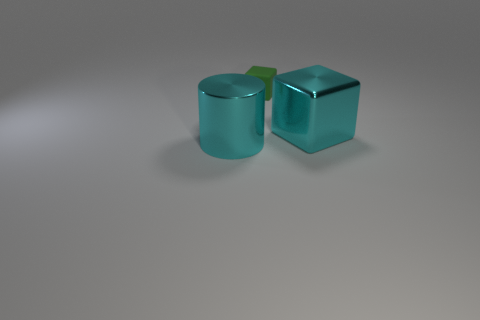Add 1 big brown rubber spheres. How many objects exist? 4 Subtract all cylinders. How many objects are left? 2 Add 3 large cyan cylinders. How many large cyan cylinders are left? 4 Add 2 green matte blocks. How many green matte blocks exist? 3 Subtract 0 brown cubes. How many objects are left? 3 Subtract all green matte objects. Subtract all tiny objects. How many objects are left? 1 